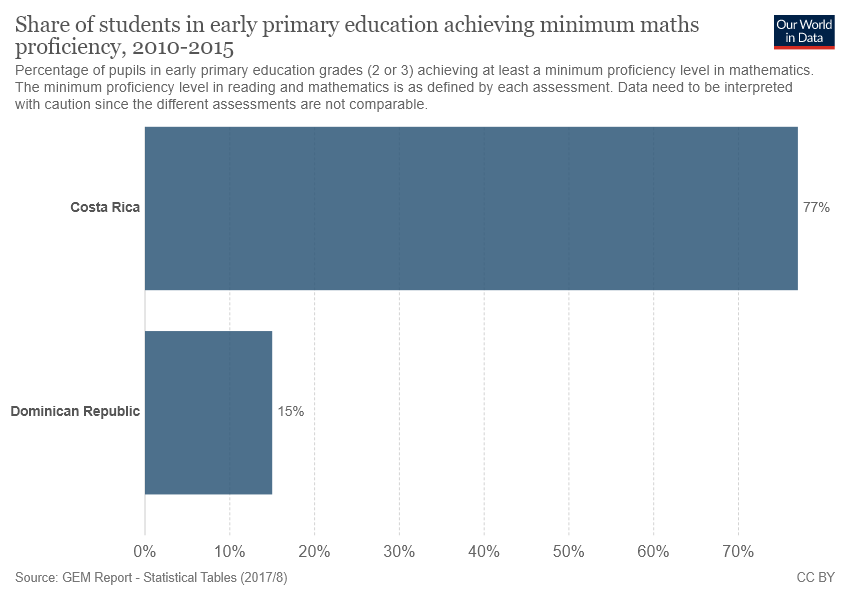Indicate a few pertinent items in this graphic. The number of colors used in the graph is 1. The value of the smallest bar is not five times the value of the largest bar. 